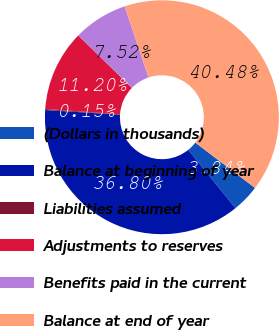<chart> <loc_0><loc_0><loc_500><loc_500><pie_chart><fcel>(Dollars in thousands)<fcel>Balance at beginning of year<fcel>Liabilities assumed<fcel>Adjustments to reserves<fcel>Benefits paid in the current<fcel>Balance at end of year<nl><fcel>3.84%<fcel>36.8%<fcel>0.15%<fcel>11.2%<fcel>7.52%<fcel>40.48%<nl></chart> 